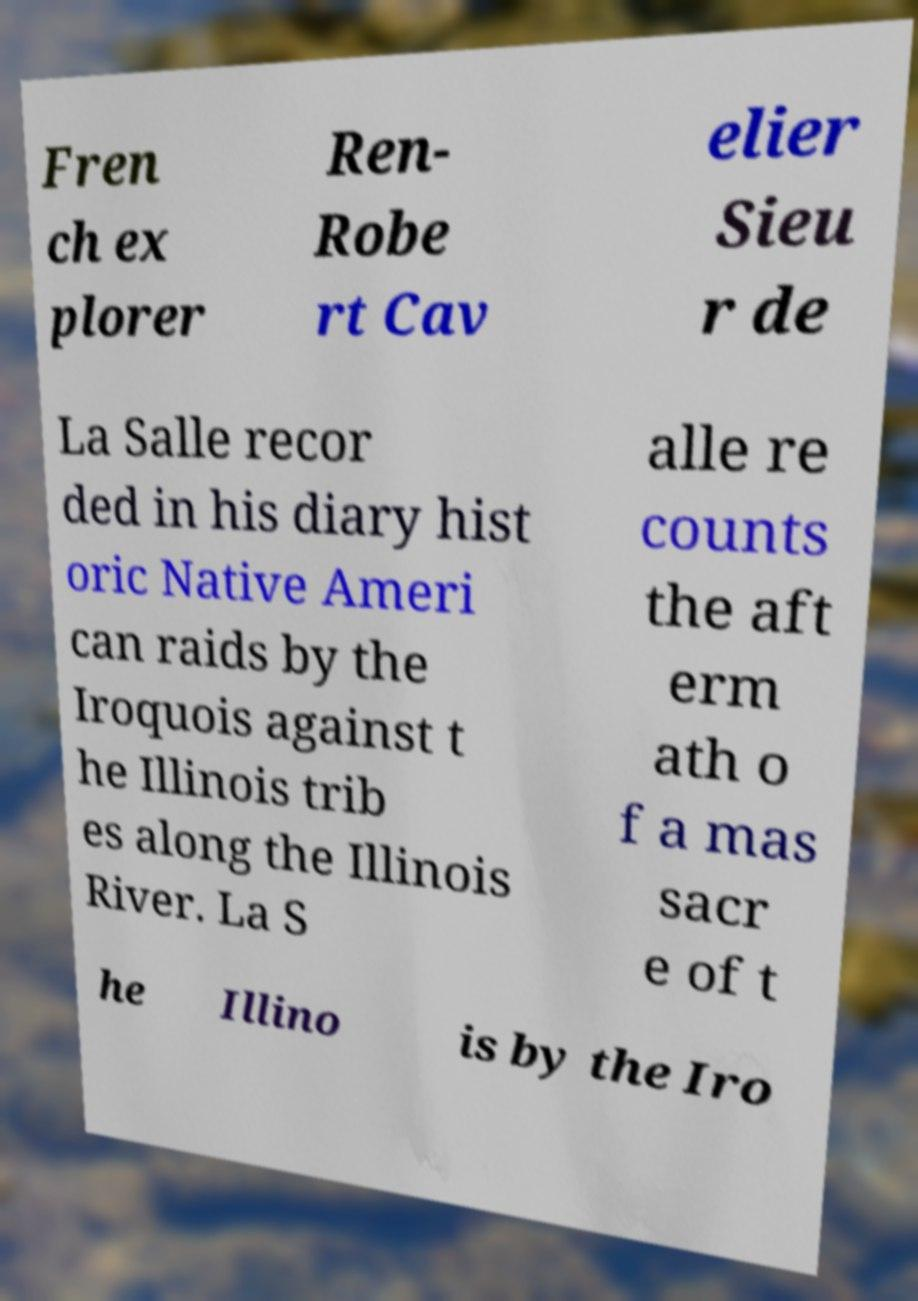Please identify and transcribe the text found in this image. Fren ch ex plorer Ren- Robe rt Cav elier Sieu r de La Salle recor ded in his diary hist oric Native Ameri can raids by the Iroquois against t he Illinois trib es along the Illinois River. La S alle re counts the aft erm ath o f a mas sacr e of t he Illino is by the Iro 